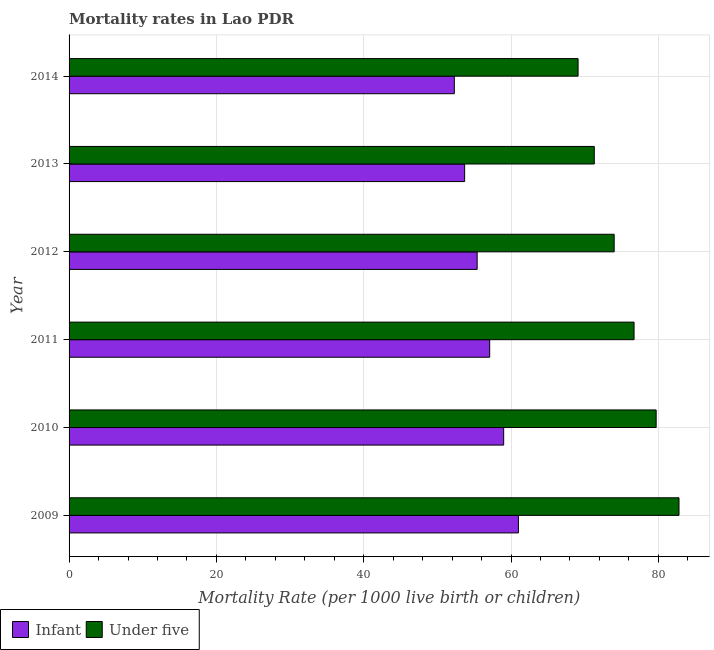How many groups of bars are there?
Give a very brief answer. 6. Are the number of bars per tick equal to the number of legend labels?
Your answer should be compact. Yes. What is the label of the 1st group of bars from the top?
Your answer should be very brief. 2014. In how many cases, is the number of bars for a given year not equal to the number of legend labels?
Your answer should be compact. 0. What is the under-5 mortality rate in 2009?
Keep it short and to the point. 82.8. Across all years, what is the maximum under-5 mortality rate?
Give a very brief answer. 82.8. Across all years, what is the minimum infant mortality rate?
Your response must be concise. 52.3. In which year was the infant mortality rate minimum?
Ensure brevity in your answer.  2014. What is the total under-5 mortality rate in the graph?
Ensure brevity in your answer.  453.6. What is the difference between the under-5 mortality rate in 2010 and that in 2014?
Your answer should be very brief. 10.6. What is the difference between the infant mortality rate in 2013 and the under-5 mortality rate in 2011?
Provide a succinct answer. -23. What is the average infant mortality rate per year?
Ensure brevity in your answer.  56.42. In the year 2011, what is the difference between the infant mortality rate and under-5 mortality rate?
Offer a terse response. -19.6. What is the ratio of the infant mortality rate in 2011 to that in 2014?
Offer a terse response. 1.09. Is the infant mortality rate in 2012 less than that in 2014?
Your response must be concise. No. In how many years, is the infant mortality rate greater than the average infant mortality rate taken over all years?
Your answer should be compact. 3. Is the sum of the under-5 mortality rate in 2011 and 2013 greater than the maximum infant mortality rate across all years?
Offer a terse response. Yes. What does the 2nd bar from the top in 2011 represents?
Provide a short and direct response. Infant. What does the 1st bar from the bottom in 2010 represents?
Offer a very short reply. Infant. How many bars are there?
Give a very brief answer. 12. What is the difference between two consecutive major ticks on the X-axis?
Keep it short and to the point. 20. Does the graph contain grids?
Ensure brevity in your answer.  Yes. Where does the legend appear in the graph?
Give a very brief answer. Bottom left. How are the legend labels stacked?
Give a very brief answer. Horizontal. What is the title of the graph?
Keep it short and to the point. Mortality rates in Lao PDR. What is the label or title of the X-axis?
Provide a succinct answer. Mortality Rate (per 1000 live birth or children). What is the label or title of the Y-axis?
Your answer should be very brief. Year. What is the Mortality Rate (per 1000 live birth or children) in Infant in 2009?
Your response must be concise. 61. What is the Mortality Rate (per 1000 live birth or children) in Under five in 2009?
Your answer should be compact. 82.8. What is the Mortality Rate (per 1000 live birth or children) in Under five in 2010?
Give a very brief answer. 79.7. What is the Mortality Rate (per 1000 live birth or children) in Infant in 2011?
Provide a succinct answer. 57.1. What is the Mortality Rate (per 1000 live birth or children) of Under five in 2011?
Provide a short and direct response. 76.7. What is the Mortality Rate (per 1000 live birth or children) of Infant in 2012?
Offer a very short reply. 55.4. What is the Mortality Rate (per 1000 live birth or children) in Infant in 2013?
Your answer should be compact. 53.7. What is the Mortality Rate (per 1000 live birth or children) of Under five in 2013?
Make the answer very short. 71.3. What is the Mortality Rate (per 1000 live birth or children) of Infant in 2014?
Give a very brief answer. 52.3. What is the Mortality Rate (per 1000 live birth or children) in Under five in 2014?
Keep it short and to the point. 69.1. Across all years, what is the maximum Mortality Rate (per 1000 live birth or children) of Under five?
Your response must be concise. 82.8. Across all years, what is the minimum Mortality Rate (per 1000 live birth or children) in Infant?
Provide a short and direct response. 52.3. Across all years, what is the minimum Mortality Rate (per 1000 live birth or children) in Under five?
Your answer should be very brief. 69.1. What is the total Mortality Rate (per 1000 live birth or children) of Infant in the graph?
Your answer should be very brief. 338.5. What is the total Mortality Rate (per 1000 live birth or children) in Under five in the graph?
Offer a terse response. 453.6. What is the difference between the Mortality Rate (per 1000 live birth or children) in Under five in 2009 and that in 2011?
Your answer should be compact. 6.1. What is the difference between the Mortality Rate (per 1000 live birth or children) of Infant in 2009 and that in 2012?
Your answer should be very brief. 5.6. What is the difference between the Mortality Rate (per 1000 live birth or children) in Infant in 2009 and that in 2013?
Make the answer very short. 7.3. What is the difference between the Mortality Rate (per 1000 live birth or children) in Under five in 2009 and that in 2014?
Your answer should be compact. 13.7. What is the difference between the Mortality Rate (per 1000 live birth or children) in Infant in 2010 and that in 2012?
Offer a terse response. 3.6. What is the difference between the Mortality Rate (per 1000 live birth or children) of Infant in 2010 and that in 2013?
Give a very brief answer. 5.3. What is the difference between the Mortality Rate (per 1000 live birth or children) in Under five in 2010 and that in 2014?
Provide a succinct answer. 10.6. What is the difference between the Mortality Rate (per 1000 live birth or children) in Infant in 2011 and that in 2012?
Offer a very short reply. 1.7. What is the difference between the Mortality Rate (per 1000 live birth or children) in Under five in 2011 and that in 2012?
Keep it short and to the point. 2.7. What is the difference between the Mortality Rate (per 1000 live birth or children) in Infant in 2011 and that in 2013?
Ensure brevity in your answer.  3.4. What is the difference between the Mortality Rate (per 1000 live birth or children) of Infant in 2011 and that in 2014?
Ensure brevity in your answer.  4.8. What is the difference between the Mortality Rate (per 1000 live birth or children) of Infant in 2012 and that in 2014?
Keep it short and to the point. 3.1. What is the difference between the Mortality Rate (per 1000 live birth or children) of Under five in 2012 and that in 2014?
Make the answer very short. 4.9. What is the difference between the Mortality Rate (per 1000 live birth or children) of Under five in 2013 and that in 2014?
Your answer should be compact. 2.2. What is the difference between the Mortality Rate (per 1000 live birth or children) of Infant in 2009 and the Mortality Rate (per 1000 live birth or children) of Under five in 2010?
Your answer should be compact. -18.7. What is the difference between the Mortality Rate (per 1000 live birth or children) of Infant in 2009 and the Mortality Rate (per 1000 live birth or children) of Under five in 2011?
Offer a terse response. -15.7. What is the difference between the Mortality Rate (per 1000 live birth or children) of Infant in 2009 and the Mortality Rate (per 1000 live birth or children) of Under five in 2012?
Your answer should be very brief. -13. What is the difference between the Mortality Rate (per 1000 live birth or children) of Infant in 2009 and the Mortality Rate (per 1000 live birth or children) of Under five in 2013?
Offer a very short reply. -10.3. What is the difference between the Mortality Rate (per 1000 live birth or children) in Infant in 2010 and the Mortality Rate (per 1000 live birth or children) in Under five in 2011?
Ensure brevity in your answer.  -17.7. What is the difference between the Mortality Rate (per 1000 live birth or children) in Infant in 2011 and the Mortality Rate (per 1000 live birth or children) in Under five in 2012?
Offer a very short reply. -16.9. What is the difference between the Mortality Rate (per 1000 live birth or children) in Infant in 2011 and the Mortality Rate (per 1000 live birth or children) in Under five in 2013?
Offer a very short reply. -14.2. What is the difference between the Mortality Rate (per 1000 live birth or children) in Infant in 2012 and the Mortality Rate (per 1000 live birth or children) in Under five in 2013?
Offer a terse response. -15.9. What is the difference between the Mortality Rate (per 1000 live birth or children) in Infant in 2012 and the Mortality Rate (per 1000 live birth or children) in Under five in 2014?
Keep it short and to the point. -13.7. What is the difference between the Mortality Rate (per 1000 live birth or children) in Infant in 2013 and the Mortality Rate (per 1000 live birth or children) in Under five in 2014?
Provide a short and direct response. -15.4. What is the average Mortality Rate (per 1000 live birth or children) of Infant per year?
Ensure brevity in your answer.  56.42. What is the average Mortality Rate (per 1000 live birth or children) in Under five per year?
Your answer should be very brief. 75.6. In the year 2009, what is the difference between the Mortality Rate (per 1000 live birth or children) in Infant and Mortality Rate (per 1000 live birth or children) in Under five?
Give a very brief answer. -21.8. In the year 2010, what is the difference between the Mortality Rate (per 1000 live birth or children) of Infant and Mortality Rate (per 1000 live birth or children) of Under five?
Offer a terse response. -20.7. In the year 2011, what is the difference between the Mortality Rate (per 1000 live birth or children) in Infant and Mortality Rate (per 1000 live birth or children) in Under five?
Provide a short and direct response. -19.6. In the year 2012, what is the difference between the Mortality Rate (per 1000 live birth or children) of Infant and Mortality Rate (per 1000 live birth or children) of Under five?
Offer a very short reply. -18.6. In the year 2013, what is the difference between the Mortality Rate (per 1000 live birth or children) in Infant and Mortality Rate (per 1000 live birth or children) in Under five?
Your answer should be compact. -17.6. In the year 2014, what is the difference between the Mortality Rate (per 1000 live birth or children) in Infant and Mortality Rate (per 1000 live birth or children) in Under five?
Keep it short and to the point. -16.8. What is the ratio of the Mortality Rate (per 1000 live birth or children) of Infant in 2009 to that in 2010?
Ensure brevity in your answer.  1.03. What is the ratio of the Mortality Rate (per 1000 live birth or children) of Under five in 2009 to that in 2010?
Ensure brevity in your answer.  1.04. What is the ratio of the Mortality Rate (per 1000 live birth or children) of Infant in 2009 to that in 2011?
Ensure brevity in your answer.  1.07. What is the ratio of the Mortality Rate (per 1000 live birth or children) of Under five in 2009 to that in 2011?
Offer a terse response. 1.08. What is the ratio of the Mortality Rate (per 1000 live birth or children) in Infant in 2009 to that in 2012?
Your answer should be compact. 1.1. What is the ratio of the Mortality Rate (per 1000 live birth or children) in Under five in 2009 to that in 2012?
Provide a short and direct response. 1.12. What is the ratio of the Mortality Rate (per 1000 live birth or children) in Infant in 2009 to that in 2013?
Give a very brief answer. 1.14. What is the ratio of the Mortality Rate (per 1000 live birth or children) of Under five in 2009 to that in 2013?
Keep it short and to the point. 1.16. What is the ratio of the Mortality Rate (per 1000 live birth or children) of Infant in 2009 to that in 2014?
Your response must be concise. 1.17. What is the ratio of the Mortality Rate (per 1000 live birth or children) in Under five in 2009 to that in 2014?
Offer a terse response. 1.2. What is the ratio of the Mortality Rate (per 1000 live birth or children) of Under five in 2010 to that in 2011?
Make the answer very short. 1.04. What is the ratio of the Mortality Rate (per 1000 live birth or children) in Infant in 2010 to that in 2012?
Make the answer very short. 1.06. What is the ratio of the Mortality Rate (per 1000 live birth or children) of Under five in 2010 to that in 2012?
Offer a very short reply. 1.08. What is the ratio of the Mortality Rate (per 1000 live birth or children) of Infant in 2010 to that in 2013?
Offer a terse response. 1.1. What is the ratio of the Mortality Rate (per 1000 live birth or children) of Under five in 2010 to that in 2013?
Keep it short and to the point. 1.12. What is the ratio of the Mortality Rate (per 1000 live birth or children) of Infant in 2010 to that in 2014?
Your answer should be compact. 1.13. What is the ratio of the Mortality Rate (per 1000 live birth or children) of Under five in 2010 to that in 2014?
Make the answer very short. 1.15. What is the ratio of the Mortality Rate (per 1000 live birth or children) of Infant in 2011 to that in 2012?
Offer a terse response. 1.03. What is the ratio of the Mortality Rate (per 1000 live birth or children) of Under five in 2011 to that in 2012?
Your response must be concise. 1.04. What is the ratio of the Mortality Rate (per 1000 live birth or children) in Infant in 2011 to that in 2013?
Offer a very short reply. 1.06. What is the ratio of the Mortality Rate (per 1000 live birth or children) in Under five in 2011 to that in 2013?
Your answer should be very brief. 1.08. What is the ratio of the Mortality Rate (per 1000 live birth or children) of Infant in 2011 to that in 2014?
Offer a terse response. 1.09. What is the ratio of the Mortality Rate (per 1000 live birth or children) of Under five in 2011 to that in 2014?
Provide a short and direct response. 1.11. What is the ratio of the Mortality Rate (per 1000 live birth or children) in Infant in 2012 to that in 2013?
Offer a very short reply. 1.03. What is the ratio of the Mortality Rate (per 1000 live birth or children) in Under five in 2012 to that in 2013?
Provide a short and direct response. 1.04. What is the ratio of the Mortality Rate (per 1000 live birth or children) in Infant in 2012 to that in 2014?
Keep it short and to the point. 1.06. What is the ratio of the Mortality Rate (per 1000 live birth or children) in Under five in 2012 to that in 2014?
Provide a short and direct response. 1.07. What is the ratio of the Mortality Rate (per 1000 live birth or children) of Infant in 2013 to that in 2014?
Give a very brief answer. 1.03. What is the ratio of the Mortality Rate (per 1000 live birth or children) of Under five in 2013 to that in 2014?
Give a very brief answer. 1.03. What is the difference between the highest and the second highest Mortality Rate (per 1000 live birth or children) in Under five?
Your answer should be very brief. 3.1. What is the difference between the highest and the lowest Mortality Rate (per 1000 live birth or children) in Infant?
Offer a very short reply. 8.7. What is the difference between the highest and the lowest Mortality Rate (per 1000 live birth or children) of Under five?
Ensure brevity in your answer.  13.7. 